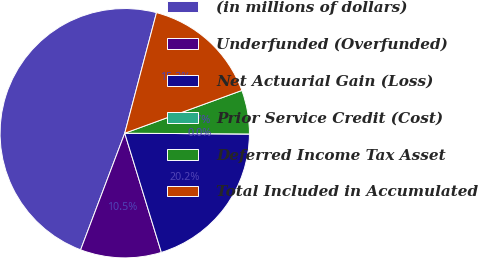Convert chart. <chart><loc_0><loc_0><loc_500><loc_500><pie_chart><fcel>(in millions of dollars)<fcel>Underfunded (Overfunded)<fcel>Net Actuarial Gain (Loss)<fcel>Prior Service Credit (Cost)<fcel>Deferred Income Tax Asset<fcel>Total Included in Accumulated<nl><fcel>48.34%<fcel>10.5%<fcel>20.16%<fcel>0.0%<fcel>5.67%<fcel>15.33%<nl></chart> 